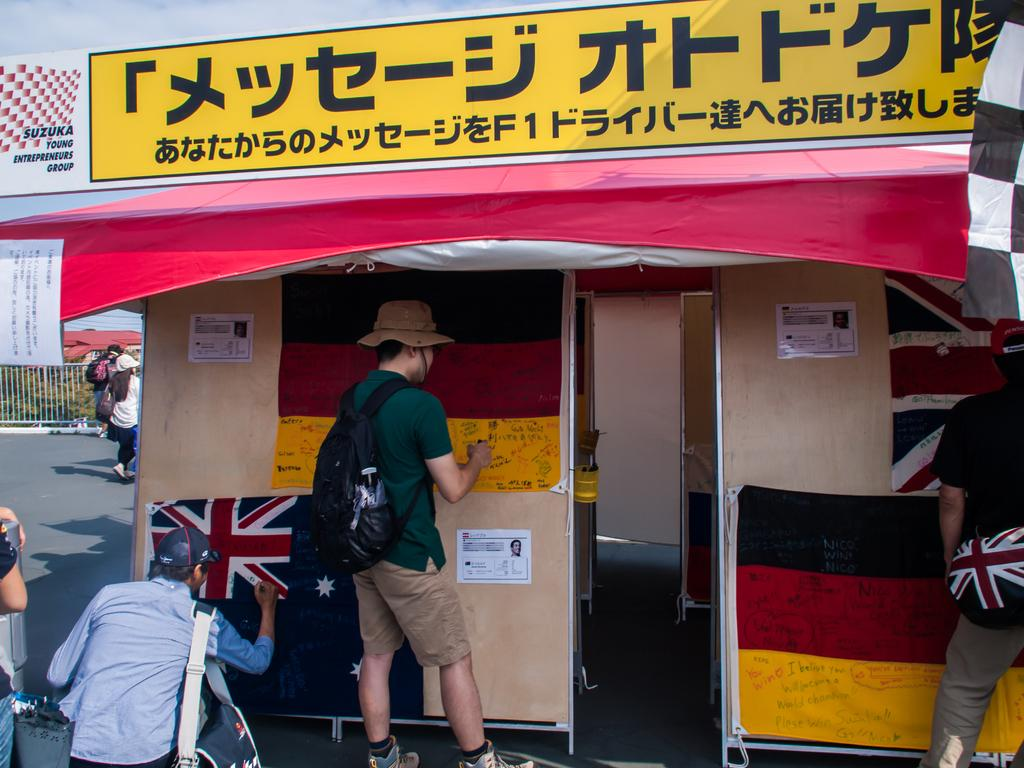<image>
Share a concise interpretation of the image provided. A small hut with flags on it sponsored by Suzuka Young Entrepreneurs Group. 